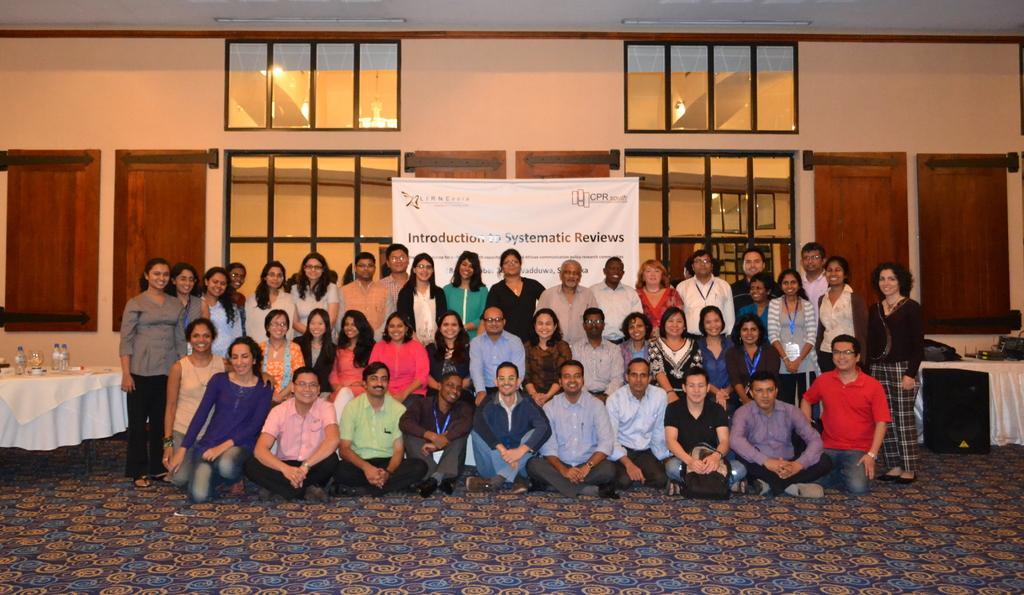In one or two sentences, can you explain what this image depicts? In this image I can see the floor, few persons sitting on the floor, few persons standing, a table with few objects on it, a speaker and a white colored banner behind them. In the background I can see the wall, the ceiling, few lights to the ceiling, few windows and few brown colored doors. 